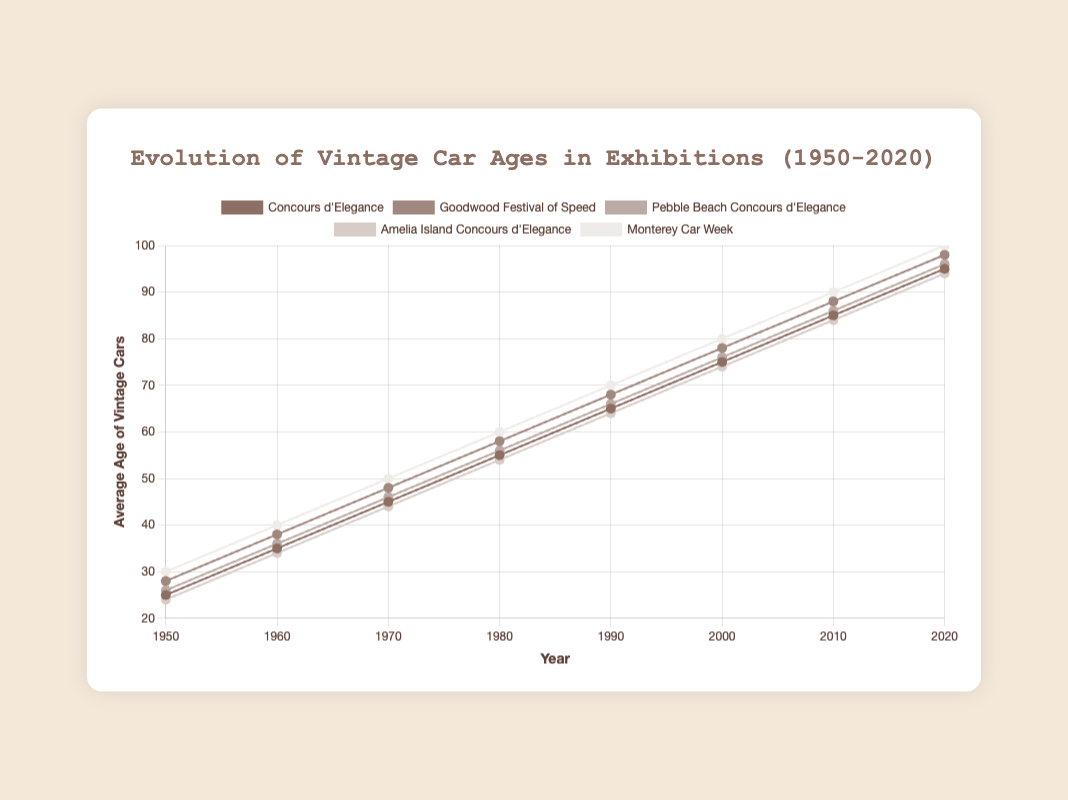What's the average age of vintage cars at Concours d'Elegance in 1980? Find the 1980 data point for the Concours d'Elegance series. The value at 1980 is 55.
Answer: 55 Between 2000 and 2020, which exhibition shows the greatest increase in average age of vintage cars? Calculate the difference between the average ages at 2020 and 2000 for all exhibitions. 
Concours_d'Elegance: 95 - 75 = 20; Goodwood_Festival_of_Speed: 98 - 78 = 20; Pebble_Beach_Concours_d'Elegance: 96 - 76 = 20; Amelia_Island_Concours_d'Elegance: 94 - 74 = 20; Monterey_Car_Week: 100 - 80 = 20. 
The increases are equal, so we need to compare across exhibitions.
Answer: Monterey Car Week Which exhibition had a lower average age of vintage cars than Pebble Beach Concours d'Elegance in 1950? Look for the 1950 data points. Pebble Beach: 26; Compare 26 with other exhibitions' 1950 values. Concours_d'Elegance: 25, Goodwood: 28, Amelia_Island: 24, Monterey: 30. Concours_d'Elegance and Amelia_Island have lower values.
Answer: Concours d'Elegance and Amelia Island Which exhibition has the brown color line? Identify the line with the brown color. The colors in the chart are mapped according to the order and Concours_d'Elegance is the first exhibition.
Answer: Concours d'Elegance In which year do all exhibitions show an average age above 50 years? Look across all exhibitions' data points for each year and find the earliest year where values are all above 50. Checking 1950-2020, the year 1980 fits.
Answer: 1980 What is the total average age for Monterey Car Week from 1950 to 2020? Sum all the average age of vintage cars for Monterey Car Week: 30 + 40 + 50 + 60 + 70 + 80 + 90 + 100 = 520
Answer: 520 Which exhibition had the smallest increase in average age from 1950 to 1960? Calculate the increases between 1950 and 1960 for all exhibitions. 
Concours_d'Elegance: 35 - 25 = 10; Goodwood_Festival_of_Speed: 38 - 28 = 10; Pebble_Beach_Concours_d'Elegance: 36 - 26 = 10; Amelia_Island_Concours_d'Elegance: 34 - 24 = 10; Monterey_Car_Week: 40 - 30 = 10. Compare all values, they are the same.
Answer: All exhibitions What is the average age of vintage cars at Goodwood Festival of Speed in the year it first exceeds 70 years? Check the data points for when the value exceeds 70 for Goodwood Festival of Speed. The first year exceeding 70 is 1990 with an age of 78.
Answer: 78 What is the difference between the average age of vintage cars at Goodwood Festival of Speed and Amelia Island Concours d'Elegance in 1980? Find the 1980 data points inside both series. Goodwood Festival of Speed's value in 1980 is 58, and Amelia Island Concours d'Elegance's value is 54.
Compute the difference: 58 - 54 = 4
Answer: 4 Which exhibition shows the highest average age of vintage cars in 2000? Compare the 2000 data points for all exhibitions: Concours_d'Elegance: 75, Goodwood_Festival_of_Speed: 78, Pebble_Beach_Concours_d'Elegance: 76, Amelia_Island_Concours_d'Elegance: 74, Monterey_Car_Week: 80. Monterey's 80 is the highest.
Answer: Monterey Car Week 